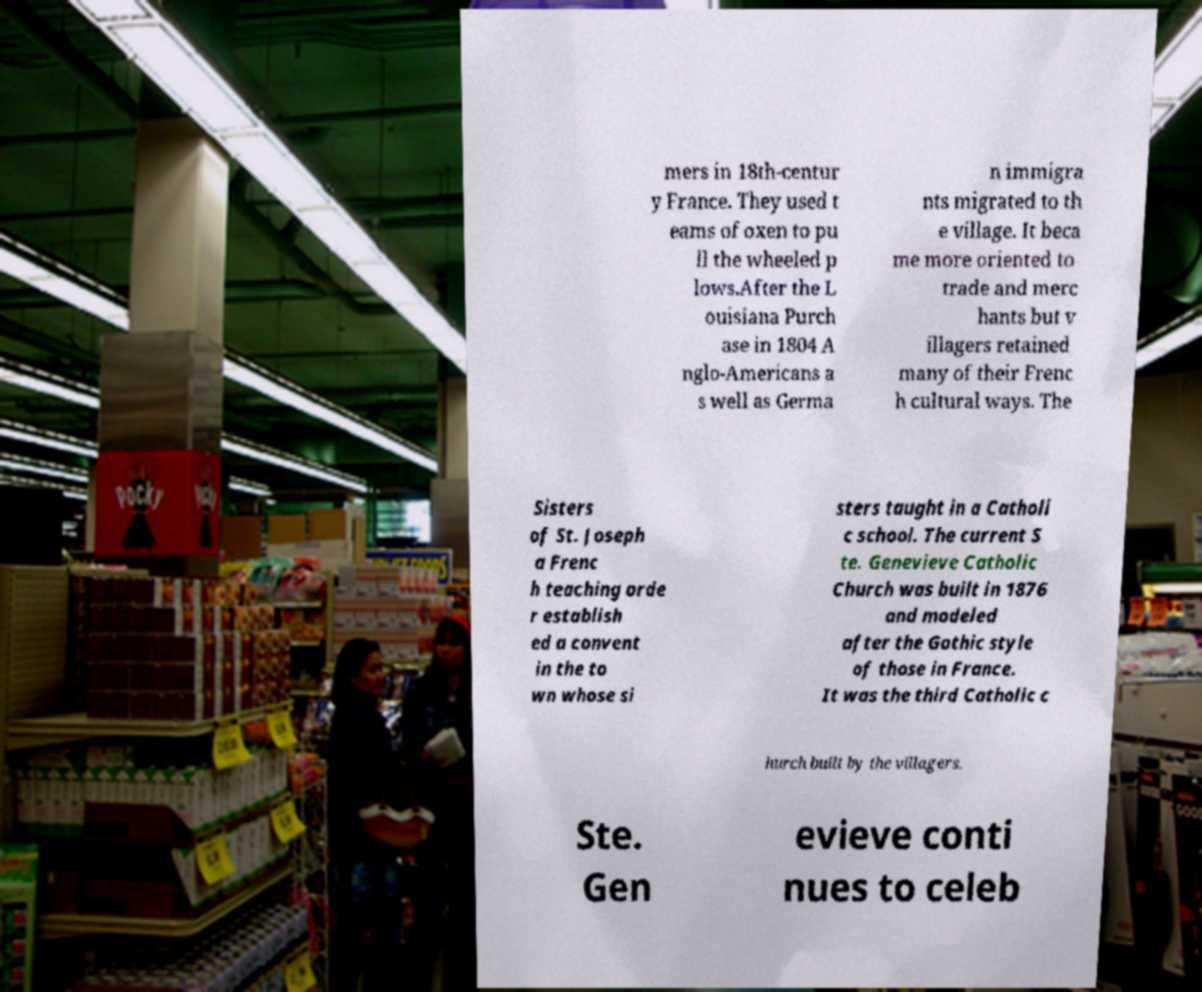Can you read and provide the text displayed in the image?This photo seems to have some interesting text. Can you extract and type it out for me? mers in 18th-centur y France. They used t eams of oxen to pu ll the wheeled p lows.After the L ouisiana Purch ase in 1804 A nglo-Americans a s well as Germa n immigra nts migrated to th e village. It beca me more oriented to trade and merc hants but v illagers retained many of their Frenc h cultural ways. The Sisters of St. Joseph a Frenc h teaching orde r establish ed a convent in the to wn whose si sters taught in a Catholi c school. The current S te. Genevieve Catholic Church was built in 1876 and modeled after the Gothic style of those in France. It was the third Catholic c hurch built by the villagers. Ste. Gen evieve conti nues to celeb 